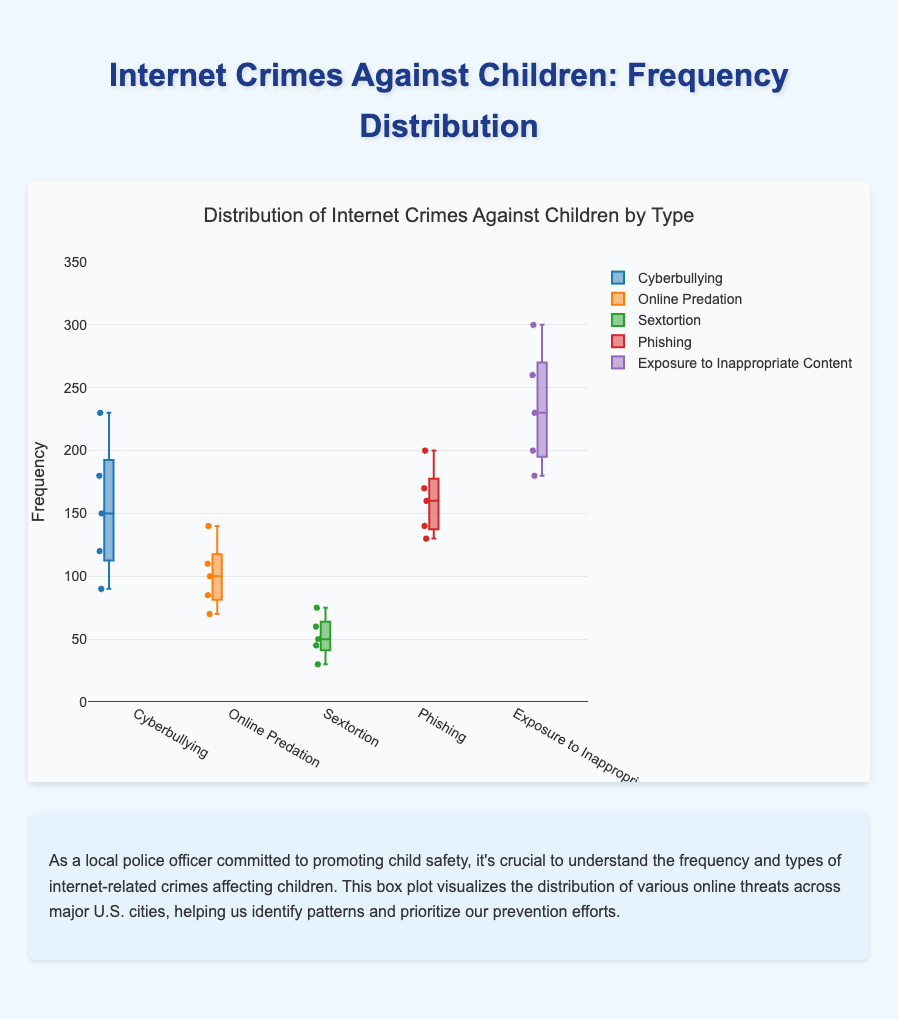What are the types of internet-related crimes shown in the figure? The figure displays different types of internet-related crimes, each represented by a separate box plot. The types highlighted are evident from the box plot labels.
Answer: Cyberbullying, Online Predation, Sextortion, Phishing, Exposure to Inappropriate Content Which city has the highest frequency of cyberbullying incidents? Look at the data points for the cyberbullying box plot. Identify the city with the highest frequency data point.
Answer: New York What is the median frequency of phishing incidents across all cities? Find the box plot for phishing. The median is represented by the line inside the box.
Answer: 160 Which type of internet crime has the widest range in frequency? Examine the box plots and compare the ranges (difference between the maximum and minimum values) of the boxes.
Answer: Exposure to Inappropriate Content Is the frequency of cyberbullying higher in New York than Los Angeles? Compare the data points (frequencies) for New York and Los Angeles within the cyberbullying box plot.
Answer: Yes What is the interquartile range (IQR) of cyberbullying incidents? IQR is the range between the first quartile (Q1) and the third quartile (Q3) values. Check the box for cyberbullying and calculate the difference between Q3 and Q1.
Answer: 90 (230-140) Which city has the lowest frequency of sextortion? Look at the data points for the sextortion box plot and identify the city with the lowest frequency value.
Answer: Phoenix Comparing 'Cyberbullying' and 'Online Predation,' which has a higher median frequency? Examine the median lines (within the boxes) for both cyberbullying and online predation. Compare the two median values.
Answer: Cyberbullying For 'Exposure to Inappropriate Content,' what city has the lowest recorded frequency? Look at the data points for 'Exposure to Inappropriate Content' and identify the city with the lowest value.
Answer: Phoenix How many data points are displayed in the ‘Online Predation’ box? There are five cities, each contributing one data point to the box plot. Count the points as they represent the data.
Answer: 5 